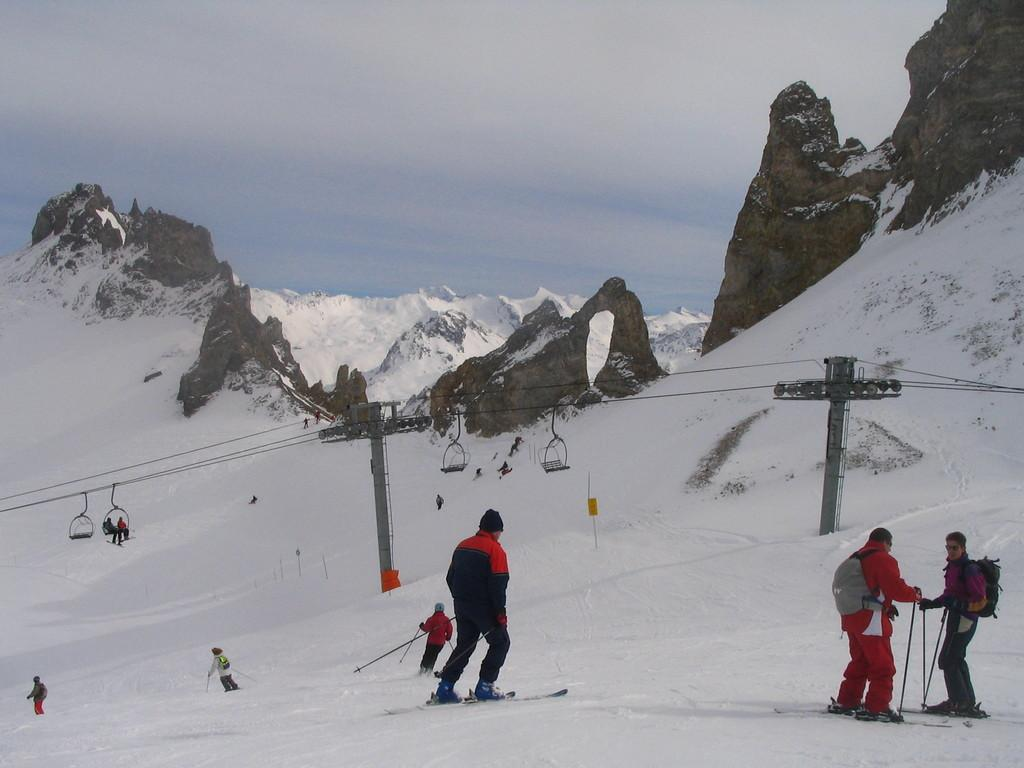Who is present in the image? There are people in the image. What are the people wearing? The people are wearing sweaters. What activity are the people engaged in? The people are skating on the ice and using skis. What can be seen in the background of the image? There is a ropeway and mountains in the background of the image, and the sky is cloudy. What type of produce is being harvested by the carpenter in the image? There is no carpenter or produce present in the image. The people in the image are skating on the ice and using skis. 